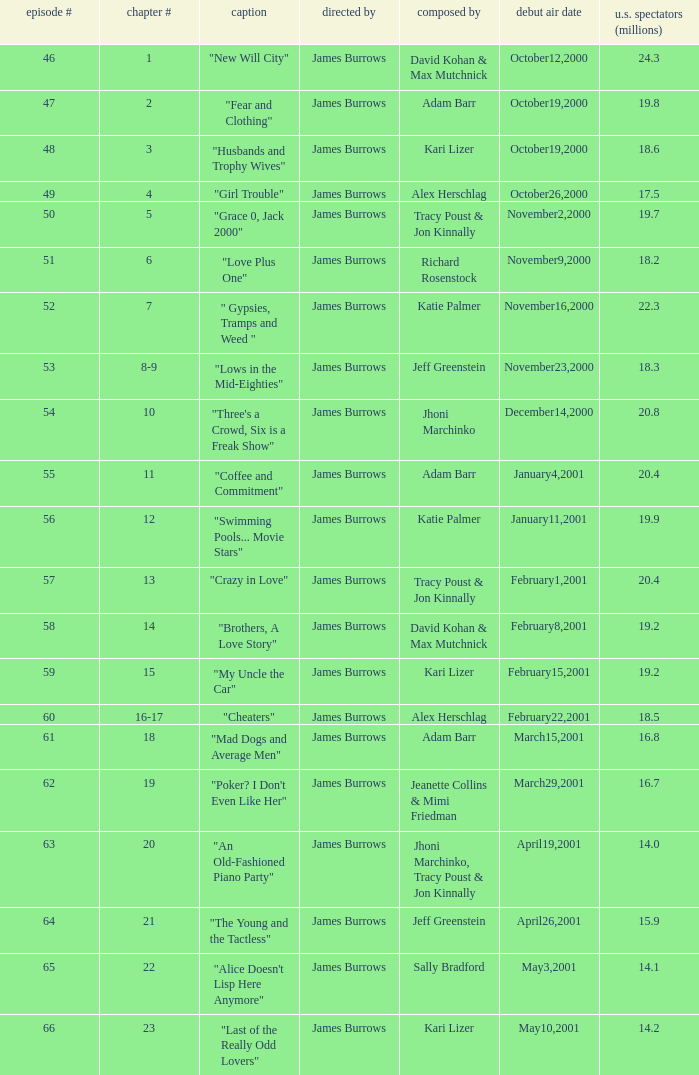Who wrote episode 23 in the season? Kari Lizer. 